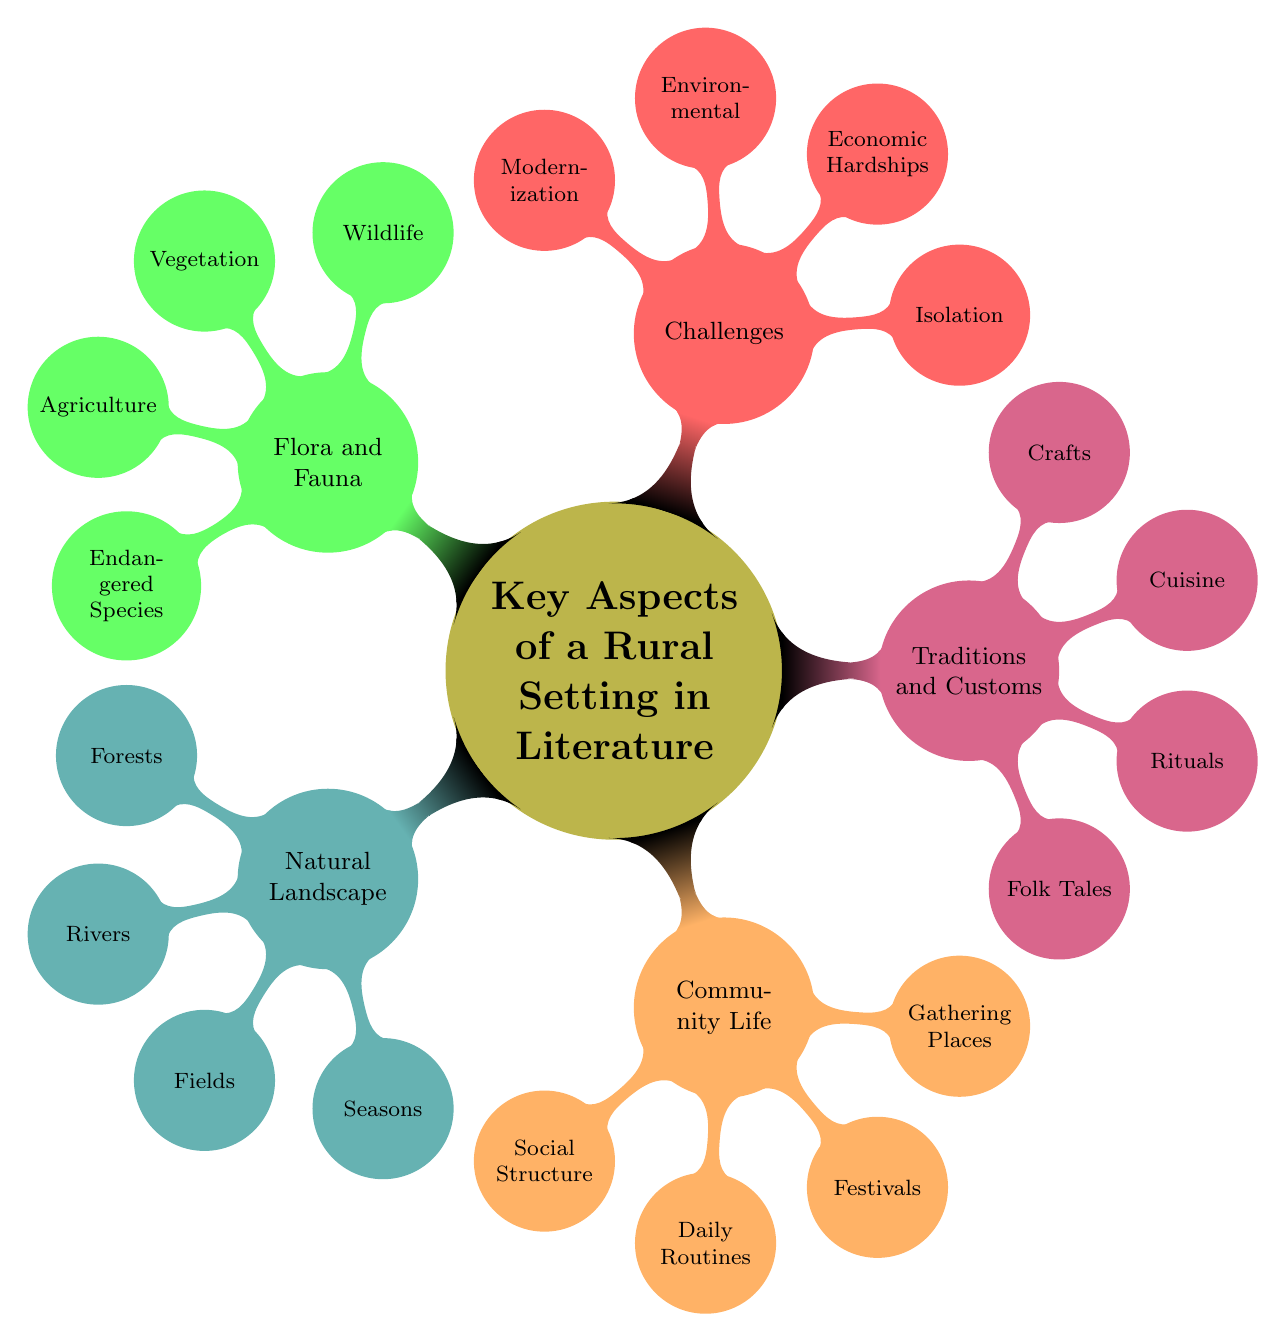What are the four main categories represented in the diagram? The diagram has five main categories branching from the central node: Natural Landscape, Community Life, Traditions and Customs, Challenges, and Flora and Fauna.
Answer: Natural Landscape, Community Life, Traditions and Customs, Challenges, Flora and Fauna Which aspect includes "Tight-Knit Communities"? "Tight-Knit Communities" is a specific item under the "Community Life" category in the diagram.
Answer: Community Life How many nodes are there under the "Flora and Fauna" category? The "Flora and Fauna" category contains four nodes: Wildlife, Vegetation, Agriculture, and Endangered Species, thus totaling four nodes.
Answer: 4 What is the relationship between "Crops Varieties" and "Endangered Species"? "Crop Varieties" is a node within the "Flora and Fauna" category, while "Endangered Species" is also within the same category, suggesting both pertain to the rural environment but focus on different aspects.
Answer: Both are under Flora and Fauna Identify a Festival mentioned in the diagram. In the diagram, "Festivals" is presented as a node under the "Community Life" category, highlighting local celebrations as an important aspect of rural living.
Answer: Festivals 